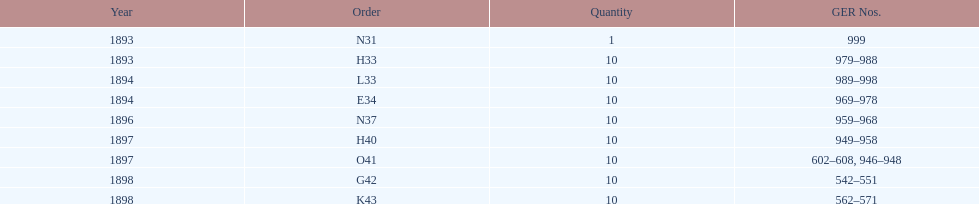What is the last year listed? 1898. Would you be able to parse every entry in this table? {'header': ['Year', 'Order', 'Quantity', 'GER Nos.'], 'rows': [['1893', 'N31', '1', '999'], ['1893', 'H33', '10', '979–988'], ['1894', 'L33', '10', '989–998'], ['1894', 'E34', '10', '969–978'], ['1896', 'N37', '10', '959–968'], ['1897', 'H40', '10', '949–958'], ['1897', 'O41', '10', '602–608, 946–948'], ['1898', 'G42', '10', '542–551'], ['1898', 'K43', '10', '562–571']]} 